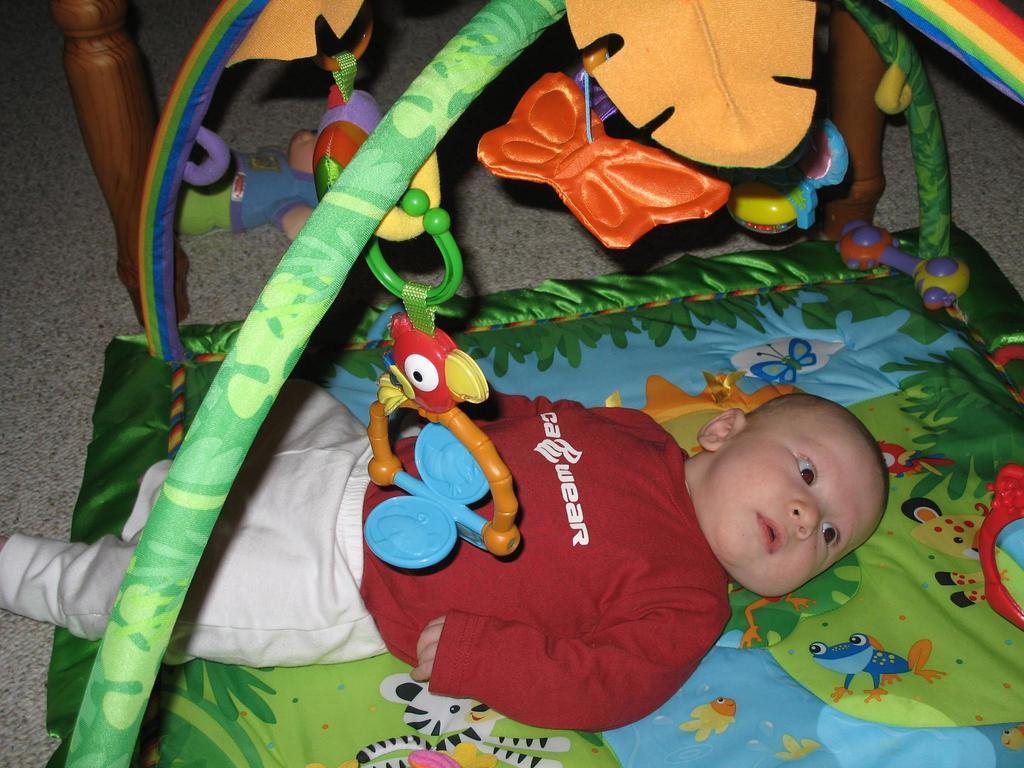Describe this image in one or two sentences. In this image there is one baby is lying on the floor as we can see in the bottom of this image and there are some wooden objects are on the top of this image. and there is an object is in middle of this image. 